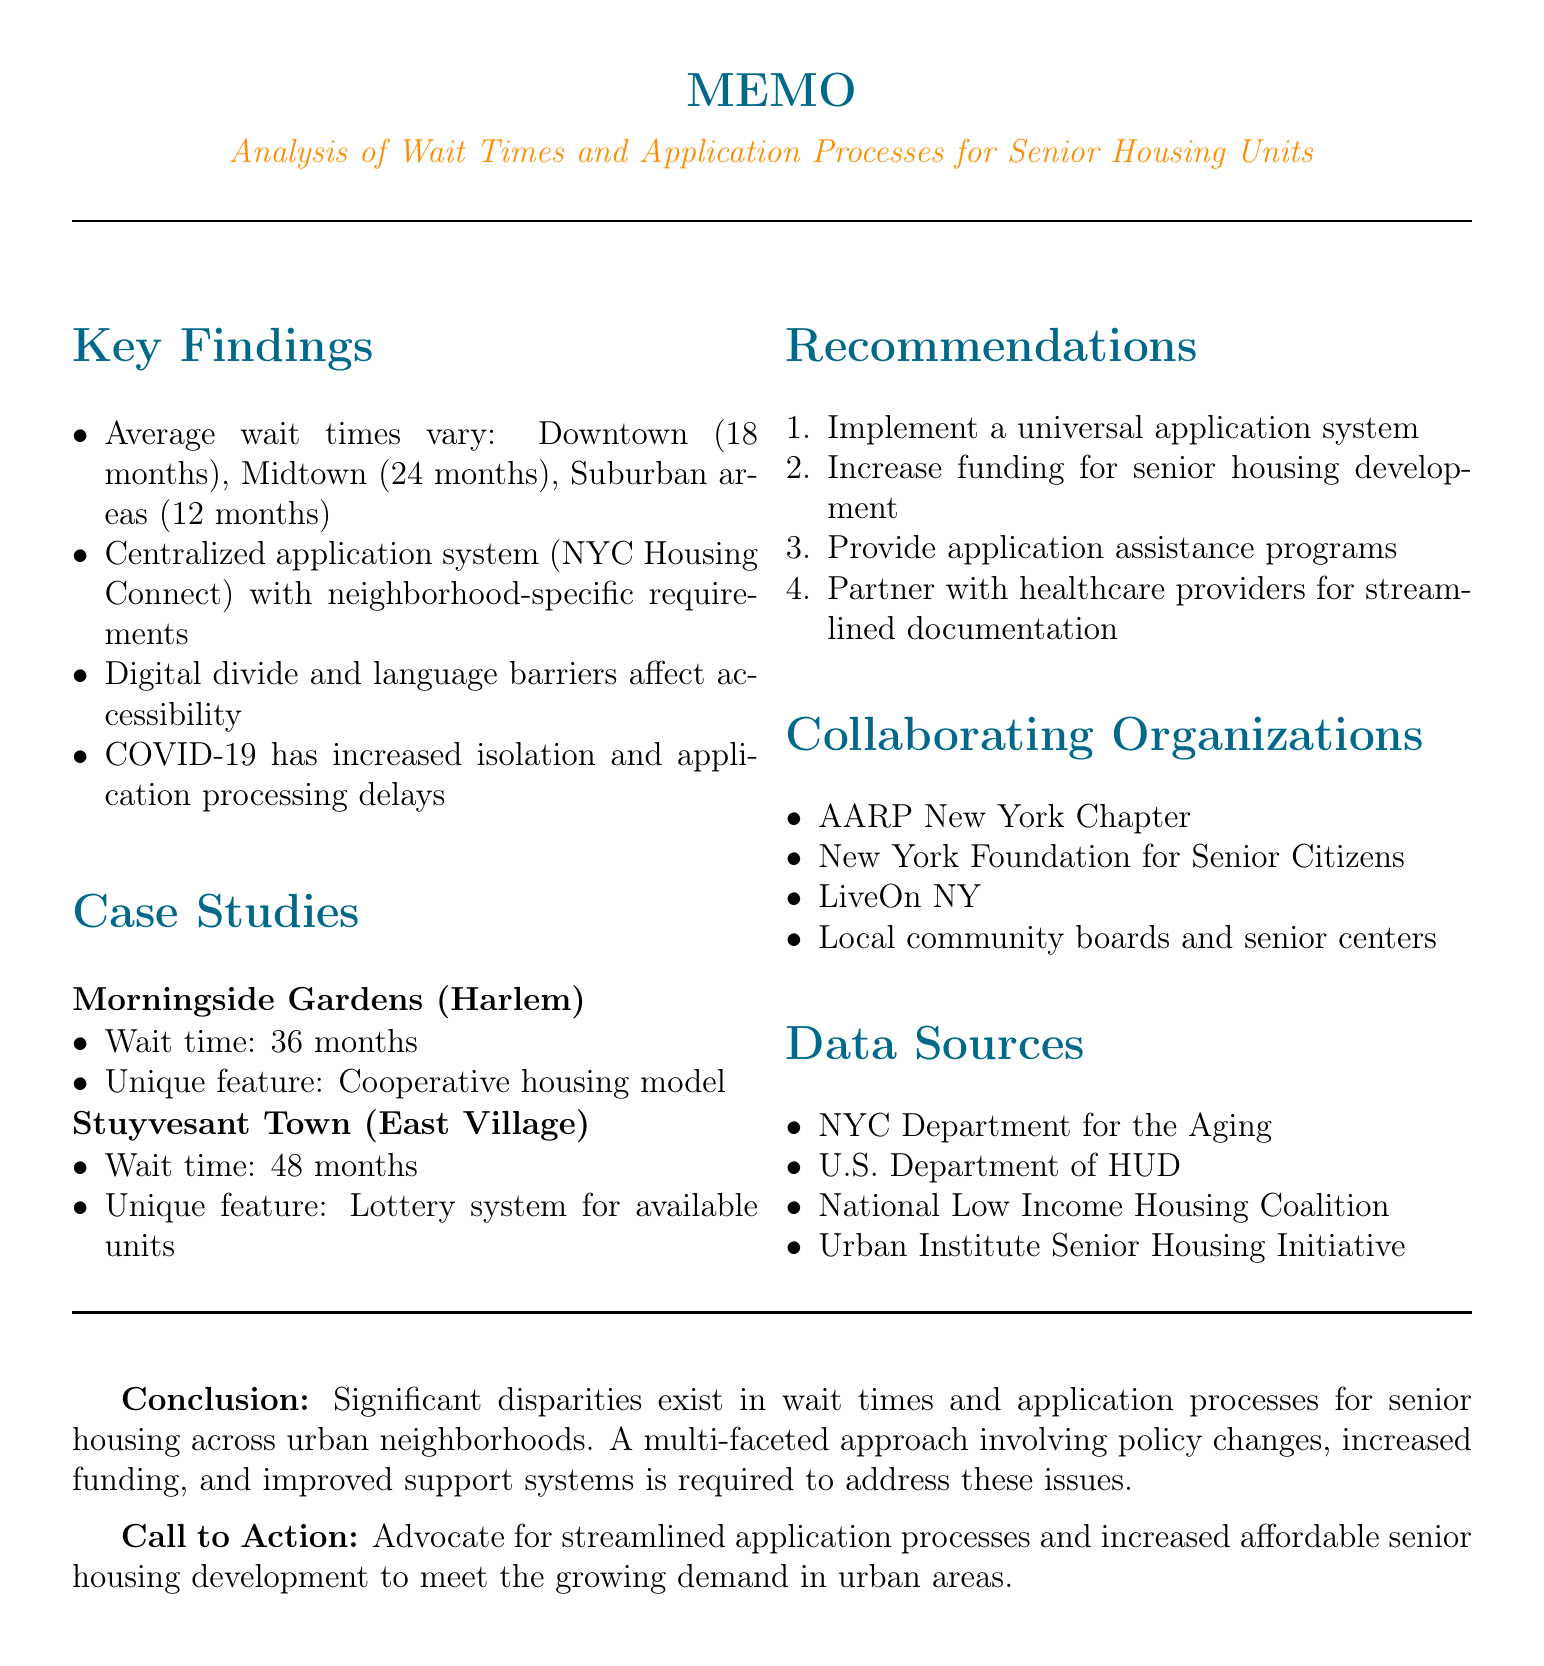what is the average wait time for senior housing in Downtown? The average wait time for senior housing in Downtown is specifically stated in the document.
Answer: 18 months what is the unique feature of Stuyvesant Town? The unique feature of Stuyvesant Town is described in the case studies section of the document.
Answer: Lottery system for available units how many months is the average wait time in Midtown? The document provides the average wait time for senior housing in Midtown.
Answer: 24 months what key barrier to access is mentioned in the document? The document lists several barriers to accessing senior housing, highlighting specific issues faced by seniors.
Answer: Digital divide which organizations are collaborating on this issue? The document lists various local organizations involved in the effort to address senior housing needs.
Answer: AARP New York Chapter what is one recommendation for improvement mentioned? Specific recommendations for improving senior housing processes are provided in the memo.
Answer: Implement a universal application system what has impacted the processing of applications due to COVID-19? The document discusses the effects of COVID-19 on senior housing applications.
Answer: Delays in processing applications what is the main topic of this memo? The document outlines the central focus and purpose of the analysis conducted.
Answer: Analysis of wait times and application processes for senior housing units across different urban neighborhoods 